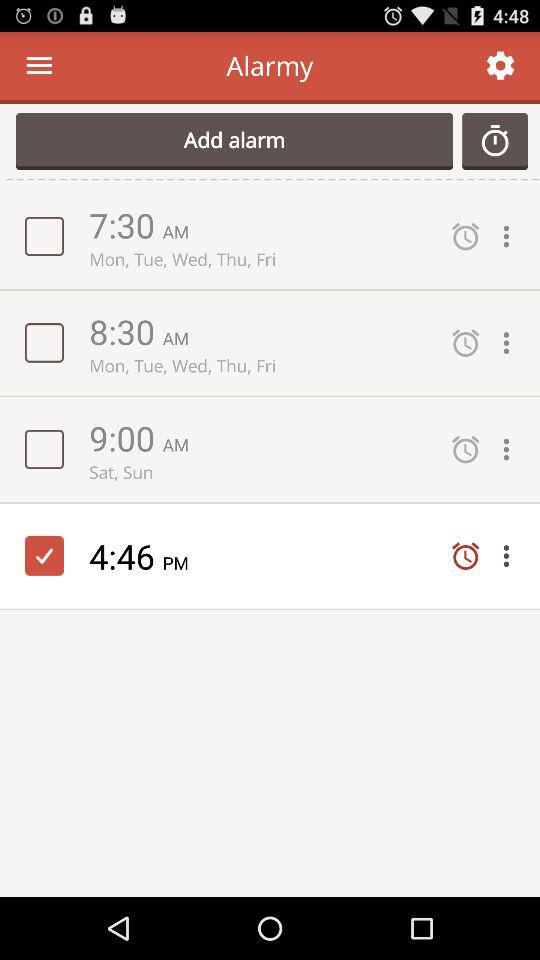How many alarms are on the screen?
Answer the question using a single word or phrase. 4 